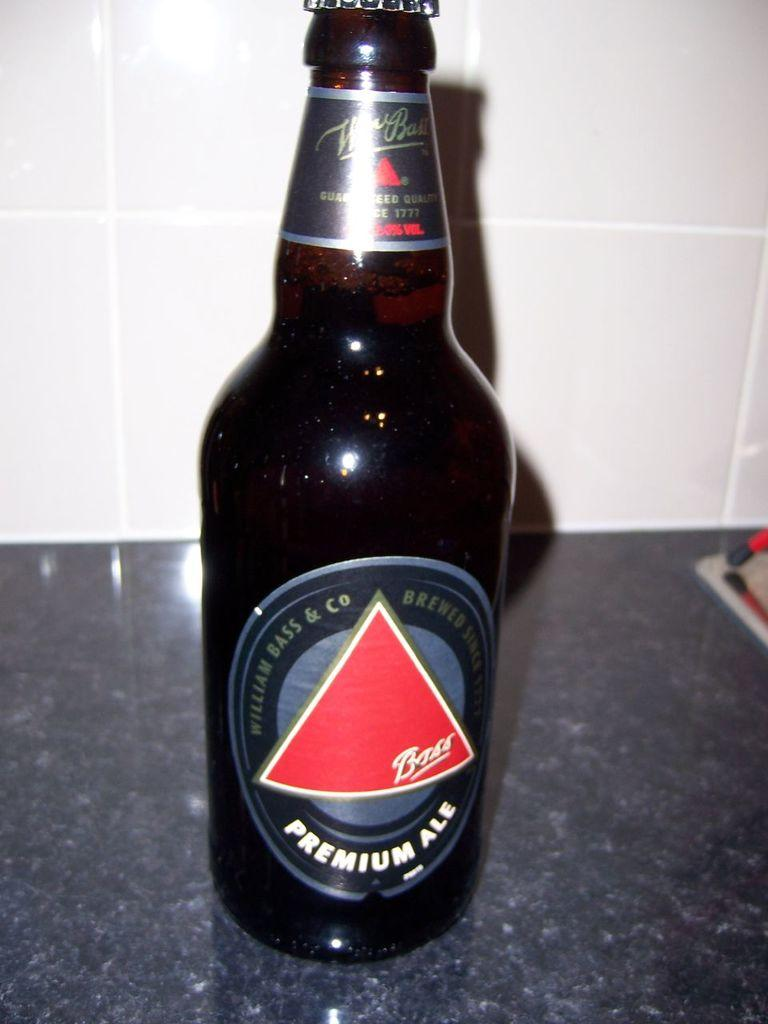<image>
Describe the image concisely. A bottle of bass liquor that is a premium ale 